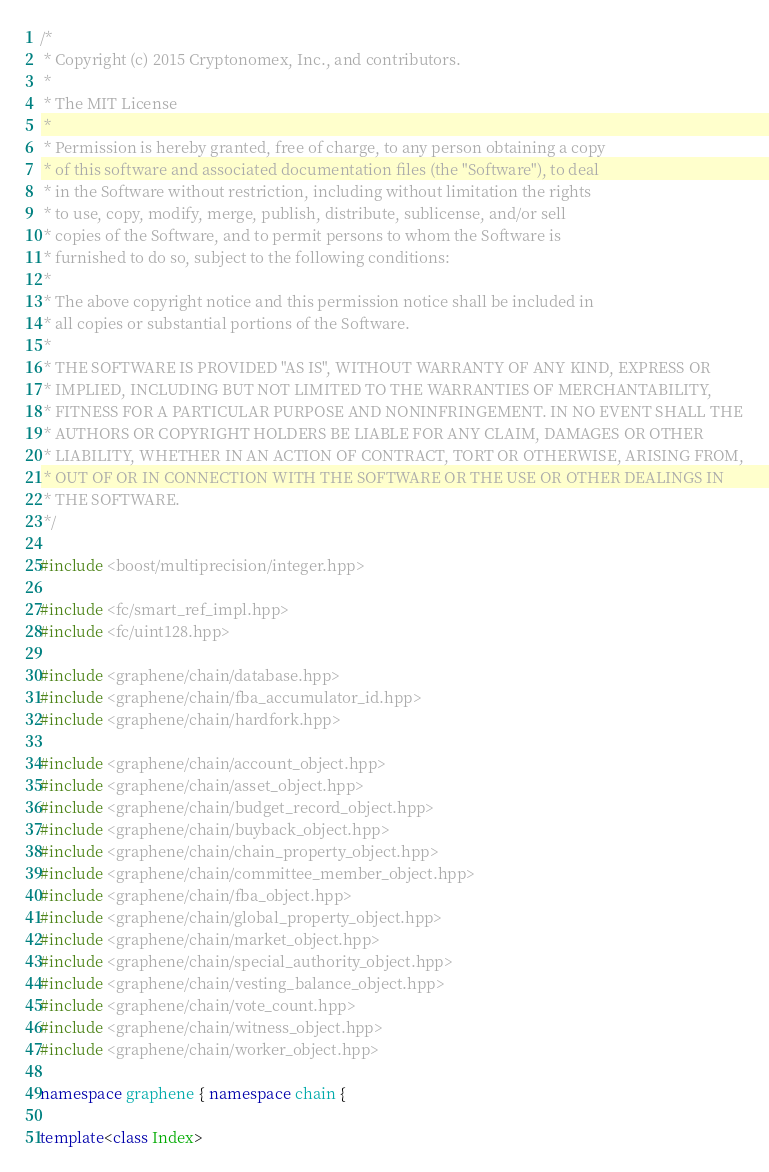<code> <loc_0><loc_0><loc_500><loc_500><_C++_>/*
 * Copyright (c) 2015 Cryptonomex, Inc., and contributors.
 *
 * The MIT License
 *
 * Permission is hereby granted, free of charge, to any person obtaining a copy
 * of this software and associated documentation files (the "Software"), to deal
 * in the Software without restriction, including without limitation the rights
 * to use, copy, modify, merge, publish, distribute, sublicense, and/or sell
 * copies of the Software, and to permit persons to whom the Software is
 * furnished to do so, subject to the following conditions:
 *
 * The above copyright notice and this permission notice shall be included in
 * all copies or substantial portions of the Software.
 *
 * THE SOFTWARE IS PROVIDED "AS IS", WITHOUT WARRANTY OF ANY KIND, EXPRESS OR
 * IMPLIED, INCLUDING BUT NOT LIMITED TO THE WARRANTIES OF MERCHANTABILITY,
 * FITNESS FOR A PARTICULAR PURPOSE AND NONINFRINGEMENT. IN NO EVENT SHALL THE
 * AUTHORS OR COPYRIGHT HOLDERS BE LIABLE FOR ANY CLAIM, DAMAGES OR OTHER
 * LIABILITY, WHETHER IN AN ACTION OF CONTRACT, TORT OR OTHERWISE, ARISING FROM,
 * OUT OF OR IN CONNECTION WITH THE SOFTWARE OR THE USE OR OTHER DEALINGS IN
 * THE SOFTWARE.
 */

#include <boost/multiprecision/integer.hpp>

#include <fc/smart_ref_impl.hpp>
#include <fc/uint128.hpp>

#include <graphene/chain/database.hpp>
#include <graphene/chain/fba_accumulator_id.hpp>
#include <graphene/chain/hardfork.hpp>

#include <graphene/chain/account_object.hpp>
#include <graphene/chain/asset_object.hpp>
#include <graphene/chain/budget_record_object.hpp>
#include <graphene/chain/buyback_object.hpp>
#include <graphene/chain/chain_property_object.hpp>
#include <graphene/chain/committee_member_object.hpp>
#include <graphene/chain/fba_object.hpp>
#include <graphene/chain/global_property_object.hpp>
#include <graphene/chain/market_object.hpp>
#include <graphene/chain/special_authority_object.hpp>
#include <graphene/chain/vesting_balance_object.hpp>
#include <graphene/chain/vote_count.hpp>
#include <graphene/chain/witness_object.hpp>
#include <graphene/chain/worker_object.hpp>

namespace graphene { namespace chain {

template<class Index></code> 